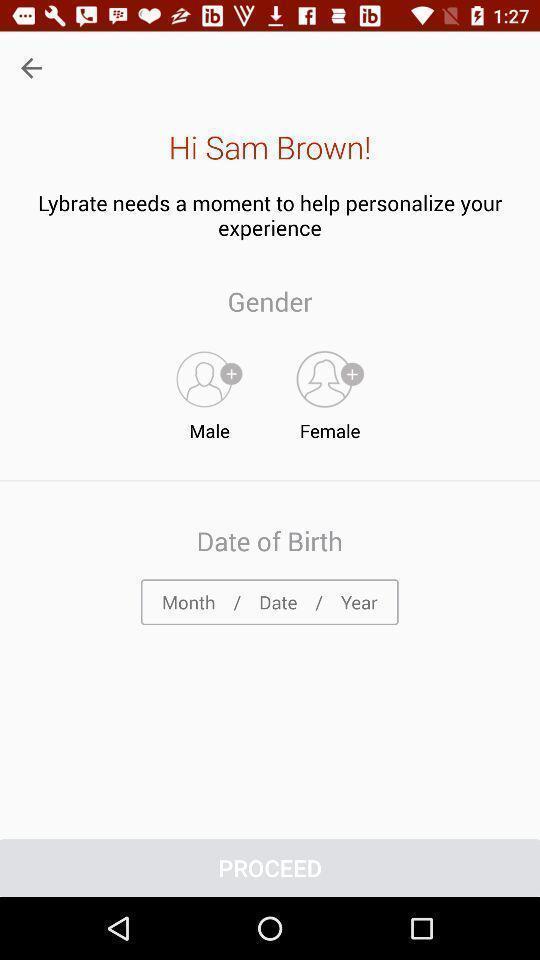Describe the visual elements of this screenshot. Welcome page. 